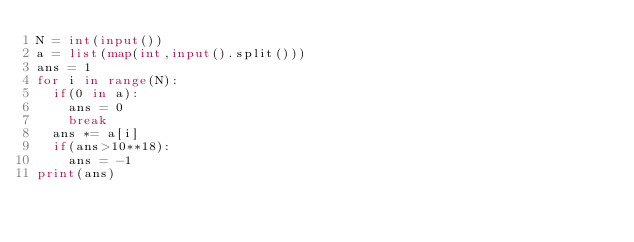Convert code to text. <code><loc_0><loc_0><loc_500><loc_500><_Python_>N = int(input())
a = list(map(int,input().split()))
ans = 1
for i in range(N):
  if(0 in a):
    ans = 0
    break
  ans *= a[i]
  if(ans>10**18):
    ans = -1
print(ans)
</code> 